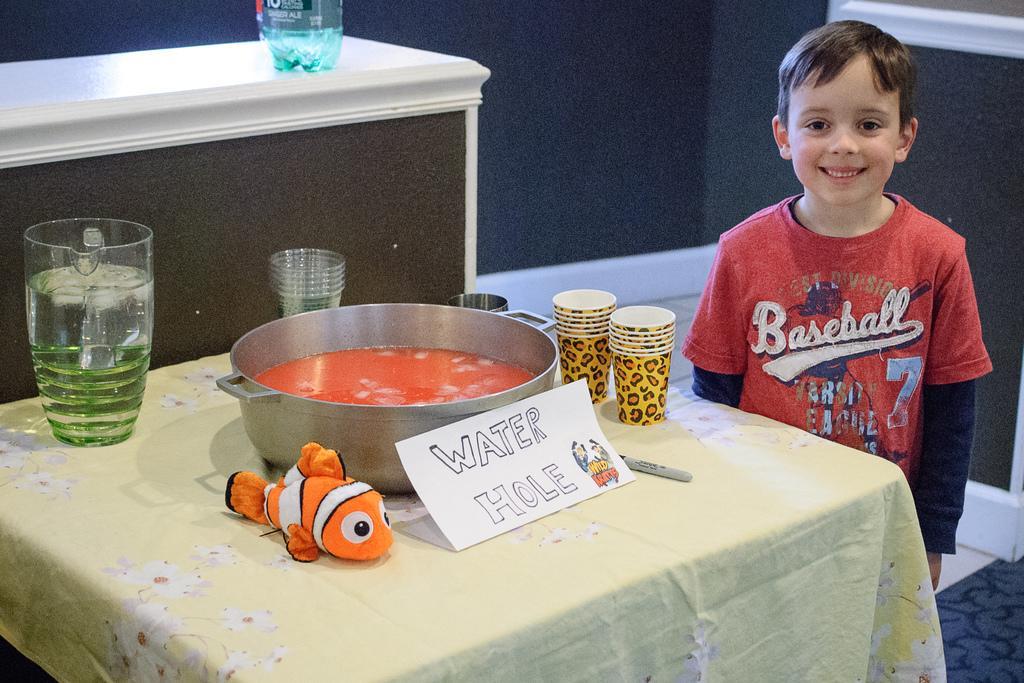How would you summarize this image in a sentence or two? This image is clicked in a room. There is a table on which a bowl, glasses and a jug are kept. To the right, there is a boy standing and wearing red t-shirt. He is also smiling. In the background, there is a wall in blue color. To the left, there is a desk on which a bottle is kept. 